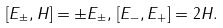Convert formula to latex. <formula><loc_0><loc_0><loc_500><loc_500>[ E _ { \pm } , H ] = \pm E _ { \pm } , \, [ E _ { - } , E _ { + } ] = 2 H .</formula> 